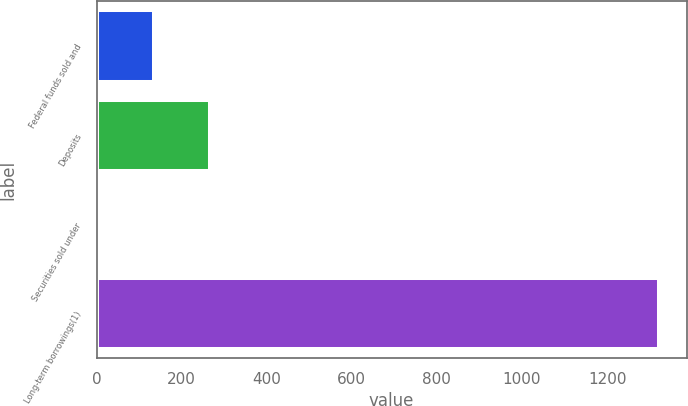Convert chart to OTSL. <chart><loc_0><loc_0><loc_500><loc_500><bar_chart><fcel>Federal funds sold and<fcel>Deposits<fcel>Securities sold under<fcel>Long-term borrowings(1)<nl><fcel>135.7<fcel>267.4<fcel>4<fcel>1321<nl></chart> 